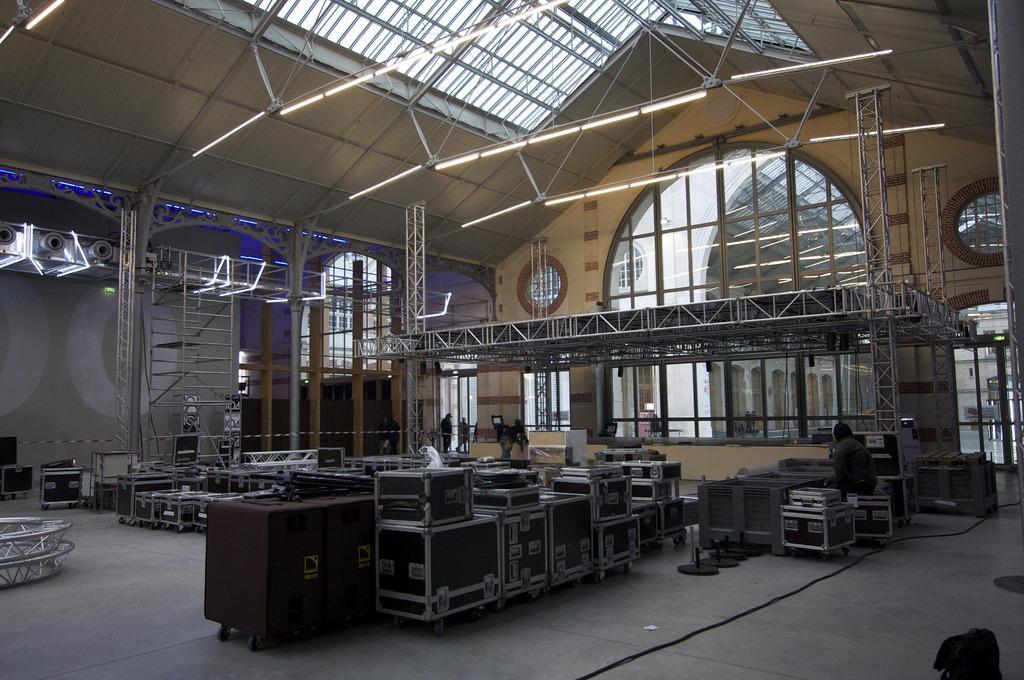Please provide a concise description of this image. In this image there is a person sitting in a chair and there are a few people walking in the entrance, in this image there are some metal boxes, metal rod ladders and some metal structures in a metal shed and glass rooftop hall supported with metal rods and glass walls and there are cables and some other objects on the surface, at the top of the image there are lights. 